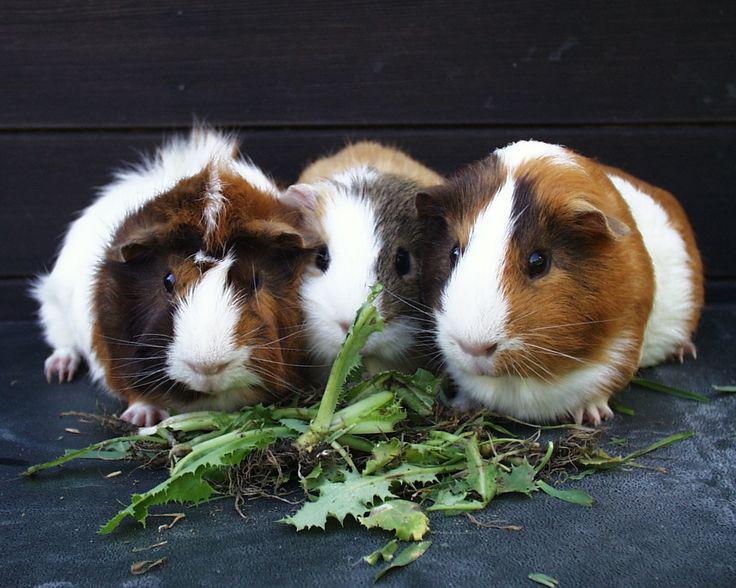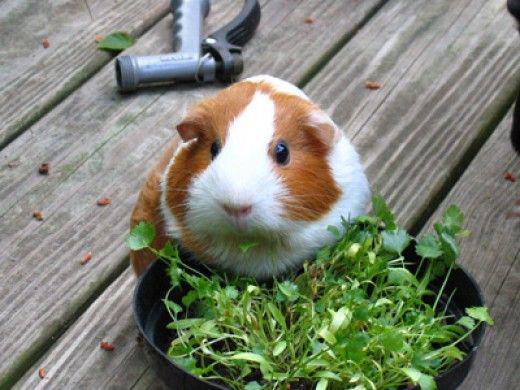The first image is the image on the left, the second image is the image on the right. For the images shown, is this caption "There are at least six guinea pigs." true? Answer yes or no. No. The first image is the image on the left, the second image is the image on the right. Assess this claim about the two images: "There are no more than four guinea pigs". Correct or not? Answer yes or no. Yes. 